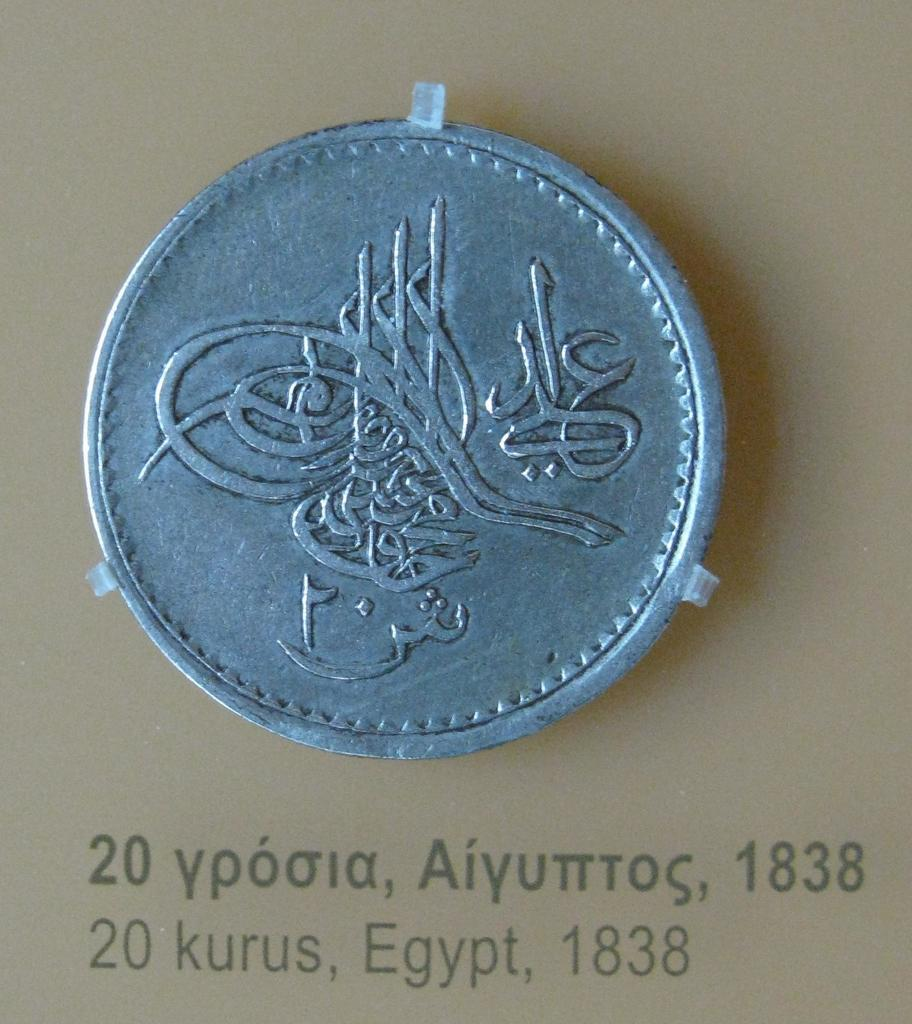<image>
Relay a brief, clear account of the picture shown. A silver colored Egyptian coin from the year 1838. 